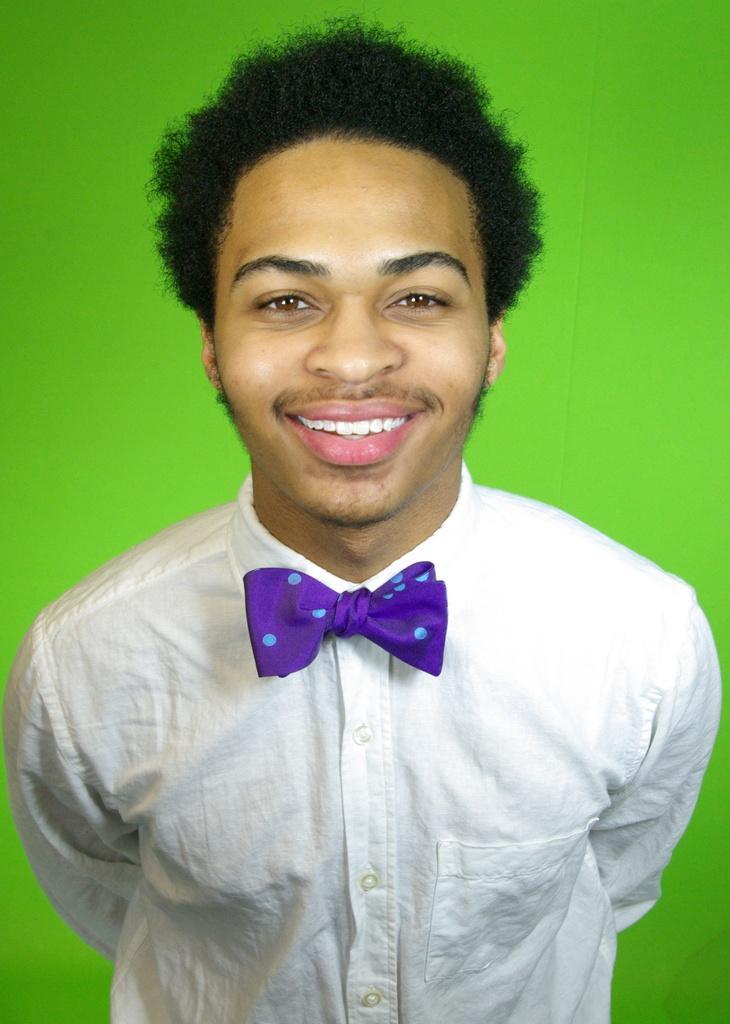Please provide a concise description of this image. In the image there is a man in white shirt and purple bow tie standing in the front and smiling, behind him there is a green screen. 